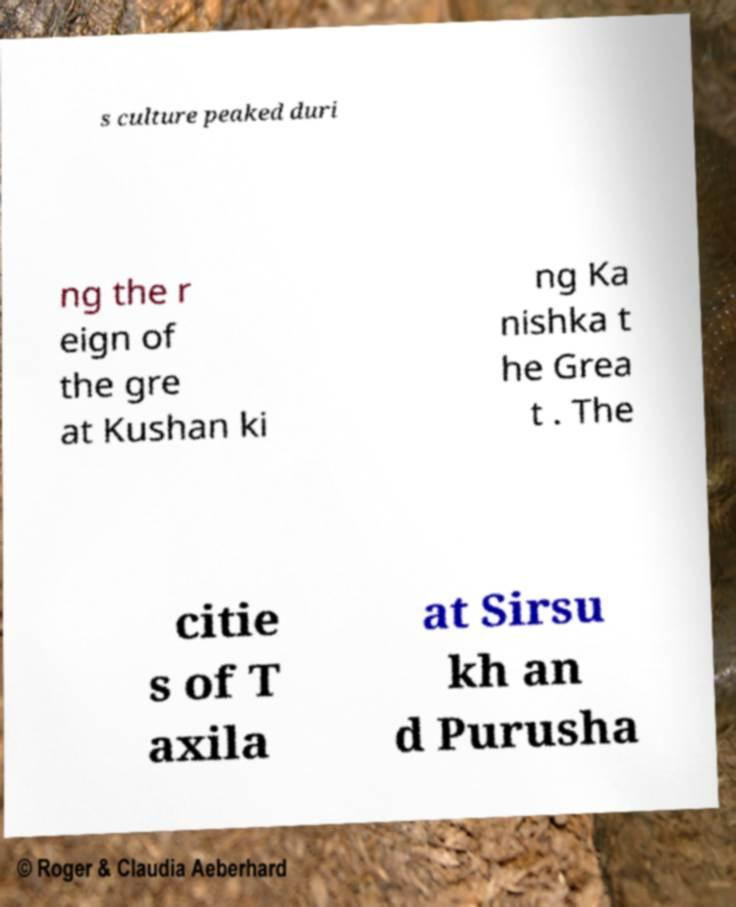There's text embedded in this image that I need extracted. Can you transcribe it verbatim? s culture peaked duri ng the r eign of the gre at Kushan ki ng Ka nishka t he Grea t . The citie s of T axila at Sirsu kh an d Purusha 